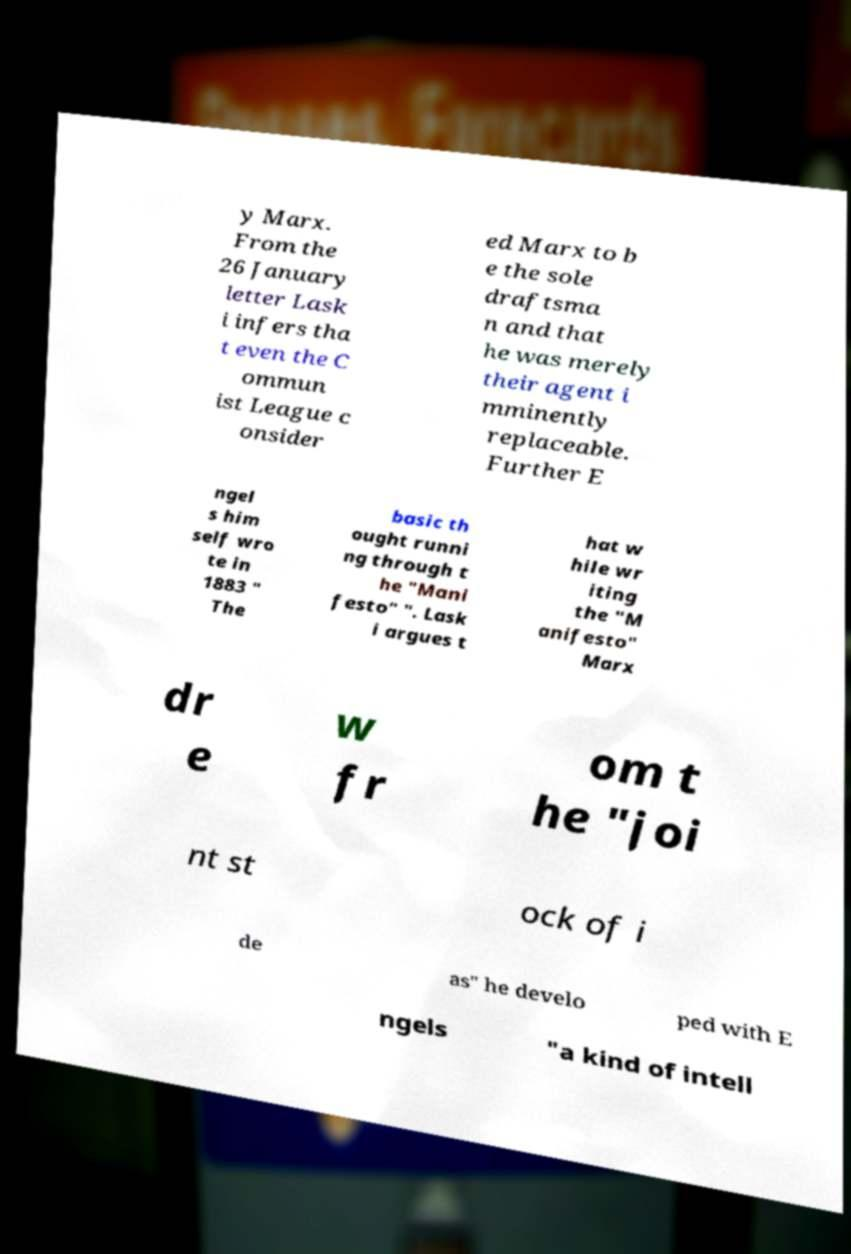Can you accurately transcribe the text from the provided image for me? y Marx. From the 26 January letter Lask i infers tha t even the C ommun ist League c onsider ed Marx to b e the sole draftsma n and that he was merely their agent i mminently replaceable. Further E ngel s him self wro te in 1883 " The basic th ought runni ng through t he "Mani festo" ". Lask i argues t hat w hile wr iting the "M anifesto" Marx dr e w fr om t he "joi nt st ock of i de as" he develo ped with E ngels "a kind of intell 